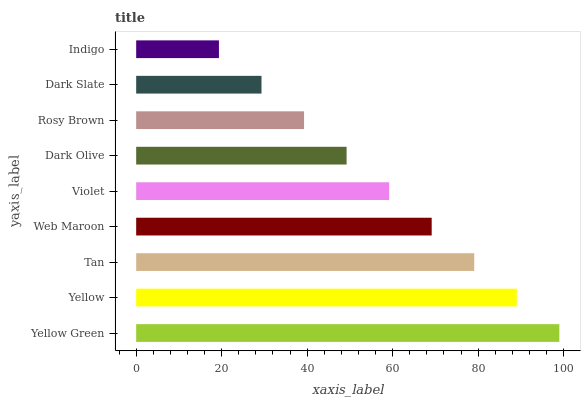Is Indigo the minimum?
Answer yes or no. Yes. Is Yellow Green the maximum?
Answer yes or no. Yes. Is Yellow the minimum?
Answer yes or no. No. Is Yellow the maximum?
Answer yes or no. No. Is Yellow Green greater than Yellow?
Answer yes or no. Yes. Is Yellow less than Yellow Green?
Answer yes or no. Yes. Is Yellow greater than Yellow Green?
Answer yes or no. No. Is Yellow Green less than Yellow?
Answer yes or no. No. Is Violet the high median?
Answer yes or no. Yes. Is Violet the low median?
Answer yes or no. Yes. Is Dark Olive the high median?
Answer yes or no. No. Is Yellow the low median?
Answer yes or no. No. 